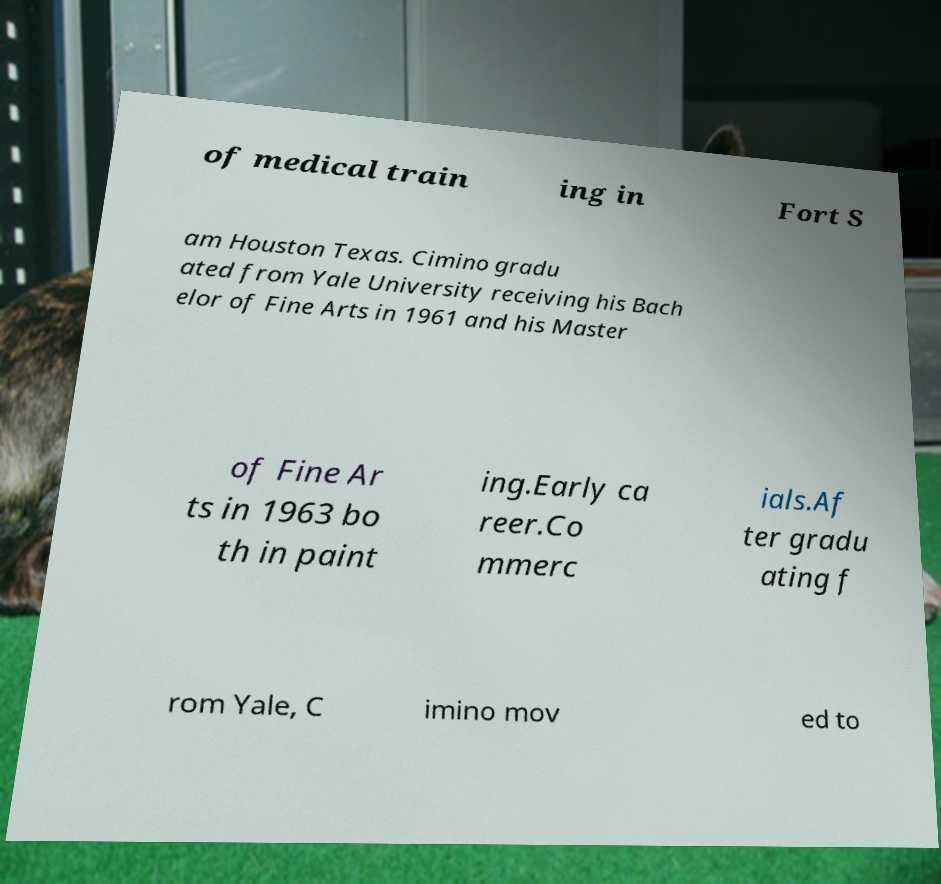There's text embedded in this image that I need extracted. Can you transcribe it verbatim? of medical train ing in Fort S am Houston Texas. Cimino gradu ated from Yale University receiving his Bach elor of Fine Arts in 1961 and his Master of Fine Ar ts in 1963 bo th in paint ing.Early ca reer.Co mmerc ials.Af ter gradu ating f rom Yale, C imino mov ed to 